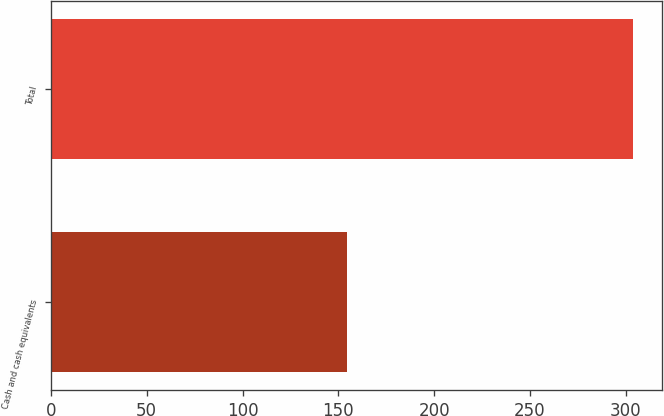<chart> <loc_0><loc_0><loc_500><loc_500><bar_chart><fcel>Cash and cash equivalents<fcel>Total<nl><fcel>154.7<fcel>303.7<nl></chart> 